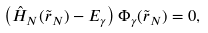Convert formula to latex. <formula><loc_0><loc_0><loc_500><loc_500>\left ( \hat { H } _ { N } ( \tilde { r } _ { N } ) - E _ { \gamma } \right ) \Phi _ { \gamma } ( \tilde { r } _ { N } ) = 0 , \\</formula> 